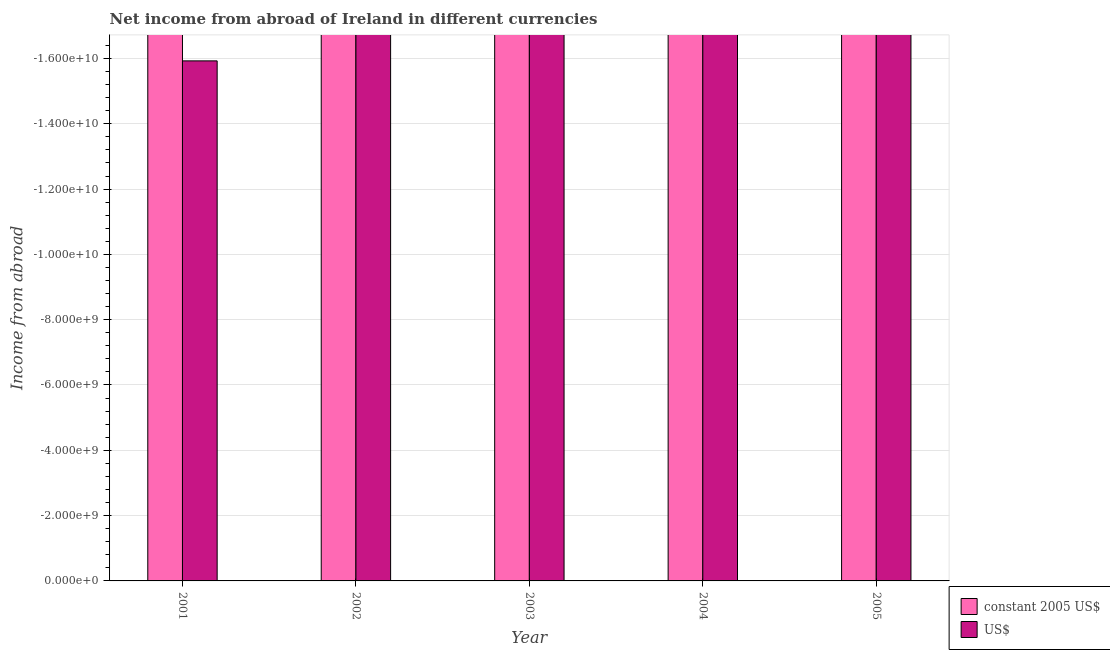Are the number of bars on each tick of the X-axis equal?
Your response must be concise. Yes. What is the label of the 5th group of bars from the left?
Provide a succinct answer. 2005. Across all years, what is the minimum income from abroad in us$?
Give a very brief answer. 0. What is the total income from abroad in constant 2005 us$ in the graph?
Provide a succinct answer. 0. What is the average income from abroad in constant 2005 us$ per year?
Your response must be concise. 0. How many bars are there?
Your response must be concise. 0. Are all the bars in the graph horizontal?
Give a very brief answer. No. How many years are there in the graph?
Keep it short and to the point. 5. Are the values on the major ticks of Y-axis written in scientific E-notation?
Your answer should be very brief. Yes. Does the graph contain any zero values?
Make the answer very short. Yes. Does the graph contain grids?
Give a very brief answer. Yes. Where does the legend appear in the graph?
Give a very brief answer. Bottom right. How are the legend labels stacked?
Give a very brief answer. Vertical. What is the title of the graph?
Your answer should be compact. Net income from abroad of Ireland in different currencies. Does "Non-resident workers" appear as one of the legend labels in the graph?
Provide a succinct answer. No. What is the label or title of the Y-axis?
Your answer should be compact. Income from abroad. What is the Income from abroad in constant 2005 US$ in 2001?
Offer a terse response. 0. What is the Income from abroad of US$ in 2001?
Make the answer very short. 0. What is the Income from abroad of US$ in 2002?
Provide a short and direct response. 0. What is the Income from abroad in US$ in 2004?
Keep it short and to the point. 0. 